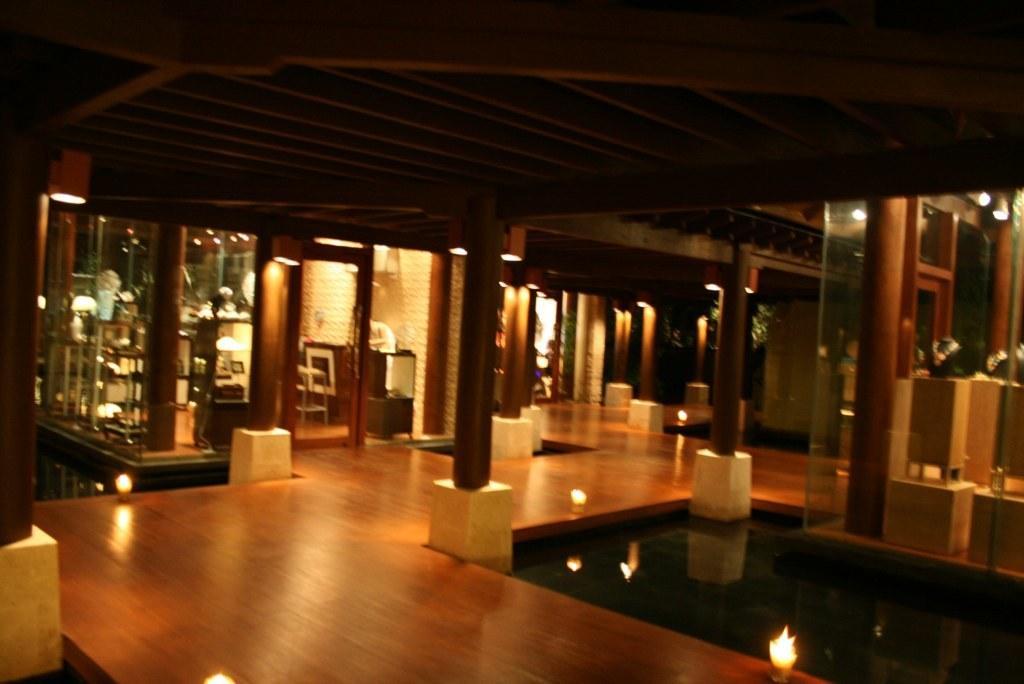In one or two sentences, can you explain what this image depicts? In this image we can see an inner view of a house containing a roof, pillars, glass doors, floor, walls and a swimming pool. 